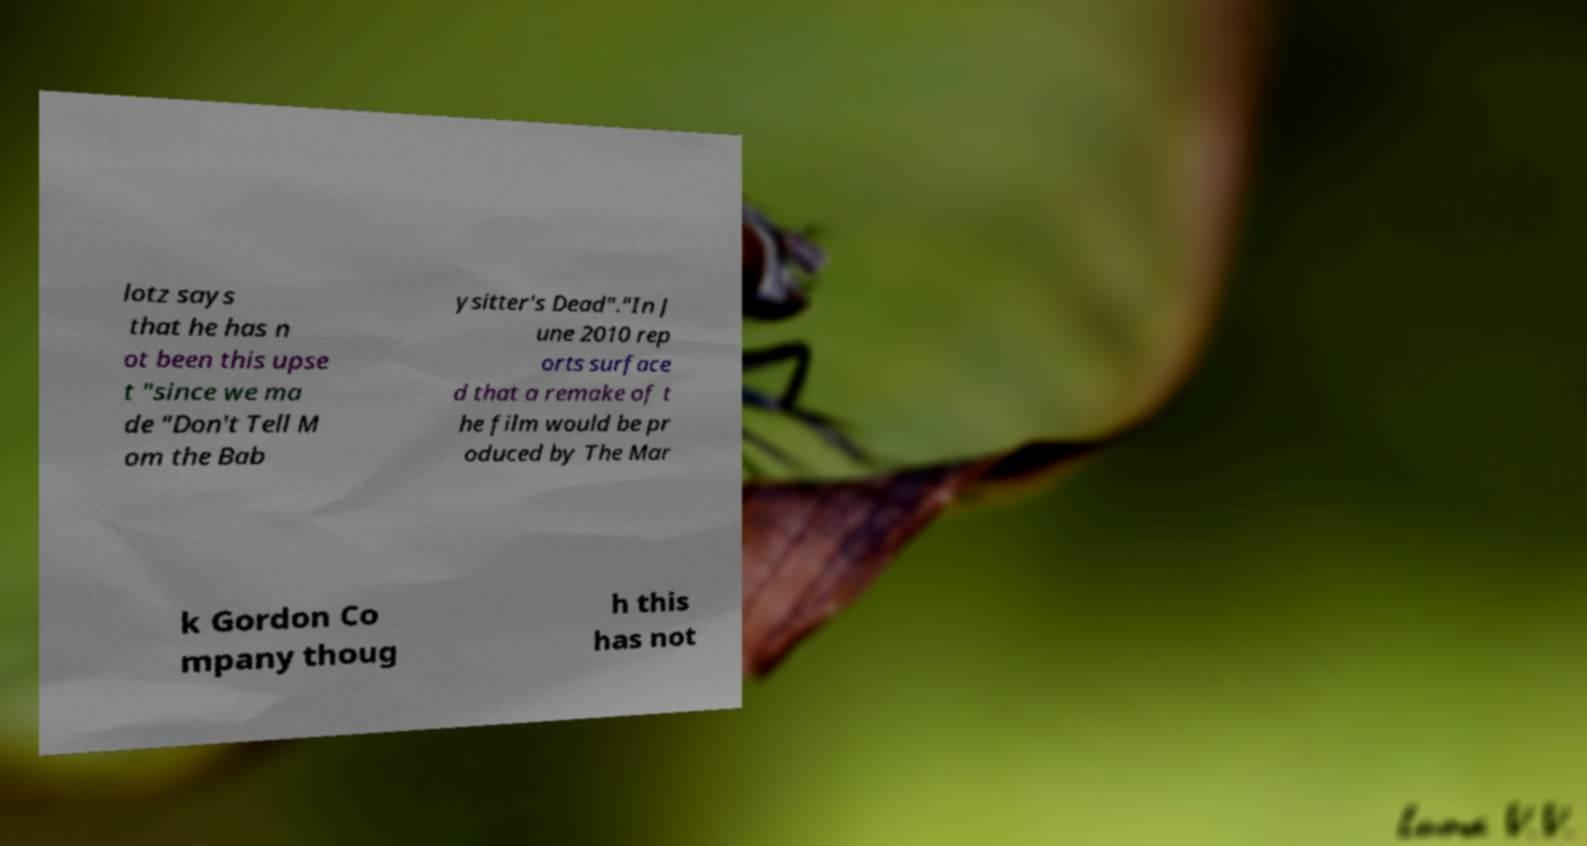Please identify and transcribe the text found in this image. lotz says that he has n ot been this upse t "since we ma de "Don't Tell M om the Bab ysitter's Dead"."In J une 2010 rep orts surface d that a remake of t he film would be pr oduced by The Mar k Gordon Co mpany thoug h this has not 